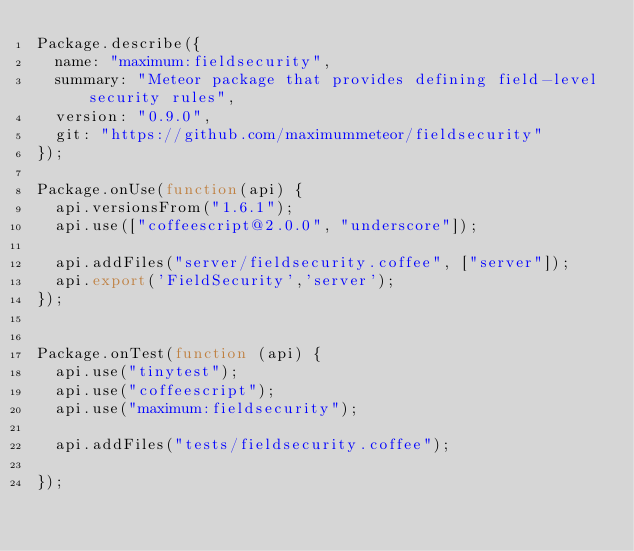Convert code to text. <code><loc_0><loc_0><loc_500><loc_500><_JavaScript_>Package.describe({
  name: "maximum:fieldsecurity",
  summary: "Meteor package that provides defining field-level security rules",
  version: "0.9.0",
  git: "https://github.com/maximummeteor/fieldsecurity"
});

Package.onUse(function(api) {
  api.versionsFrom("1.6.1");
  api.use(["coffeescript@2.0.0", "underscore"]);

  api.addFiles("server/fieldsecurity.coffee", ["server"]);
  api.export('FieldSecurity','server');
});


Package.onTest(function (api) {
  api.use("tinytest");
  api.use("coffeescript");
  api.use("maximum:fieldsecurity");

  api.addFiles("tests/fieldsecurity.coffee");

});
</code> 